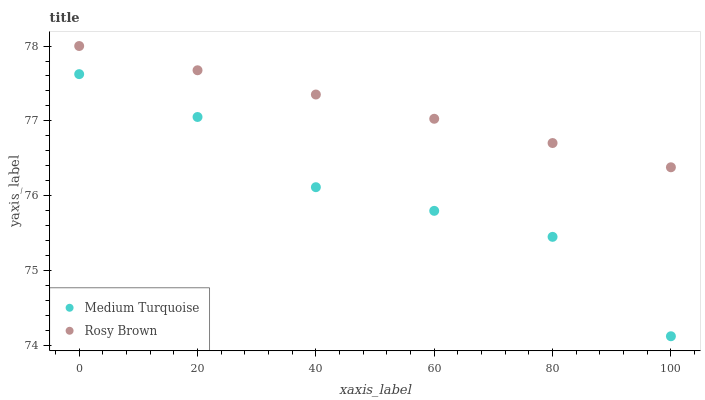Does Medium Turquoise have the minimum area under the curve?
Answer yes or no. Yes. Does Rosy Brown have the maximum area under the curve?
Answer yes or no. Yes. Does Medium Turquoise have the maximum area under the curve?
Answer yes or no. No. Is Rosy Brown the smoothest?
Answer yes or no. Yes. Is Medium Turquoise the roughest?
Answer yes or no. Yes. Is Medium Turquoise the smoothest?
Answer yes or no. No. Does Medium Turquoise have the lowest value?
Answer yes or no. Yes. Does Rosy Brown have the highest value?
Answer yes or no. Yes. Does Medium Turquoise have the highest value?
Answer yes or no. No. Is Medium Turquoise less than Rosy Brown?
Answer yes or no. Yes. Is Rosy Brown greater than Medium Turquoise?
Answer yes or no. Yes. Does Medium Turquoise intersect Rosy Brown?
Answer yes or no. No. 